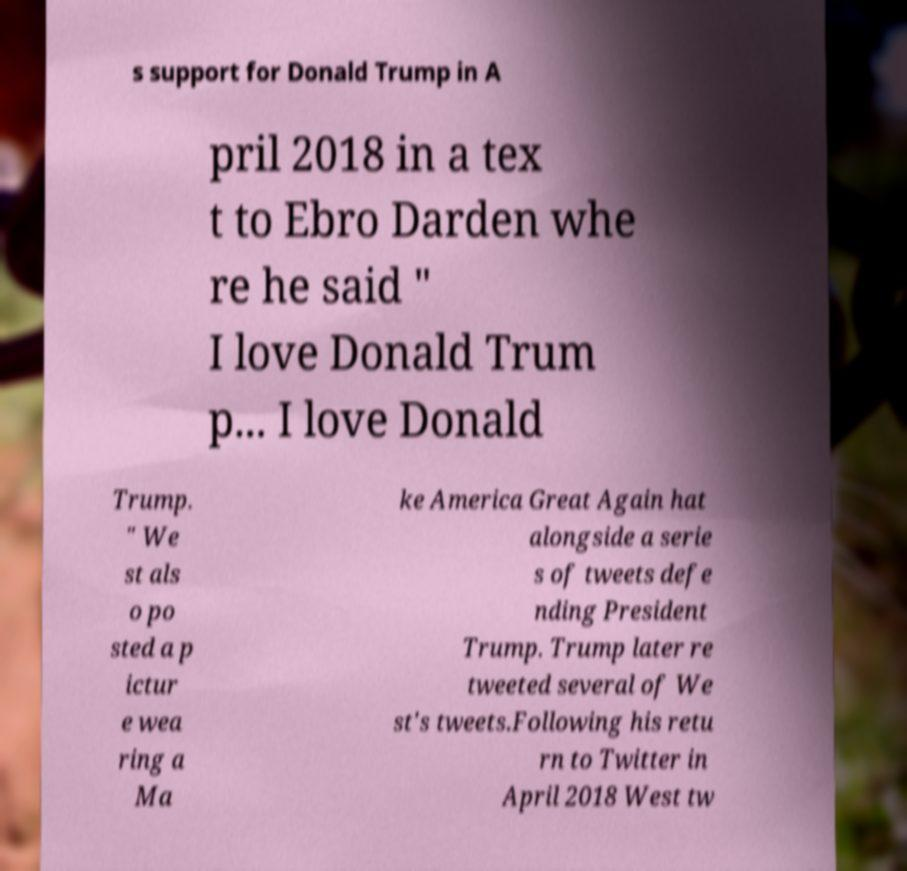What messages or text are displayed in this image? I need them in a readable, typed format. s support for Donald Trump in A pril 2018 in a tex t to Ebro Darden whe re he said " I love Donald Trum p... I love Donald Trump. " We st als o po sted a p ictur e wea ring a Ma ke America Great Again hat alongside a serie s of tweets defe nding President Trump. Trump later re tweeted several of We st's tweets.Following his retu rn to Twitter in April 2018 West tw 